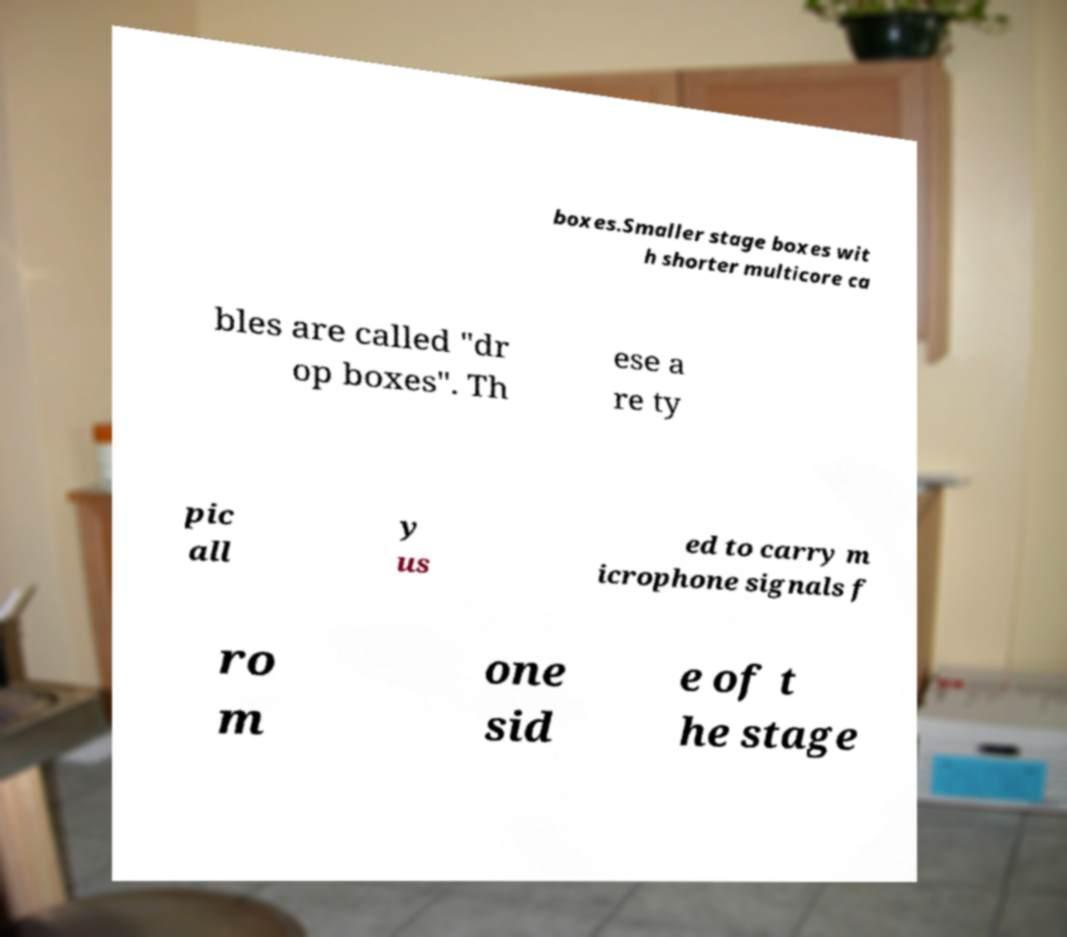Please read and relay the text visible in this image. What does it say? boxes.Smaller stage boxes wit h shorter multicore ca bles are called "dr op boxes". Th ese a re ty pic all y us ed to carry m icrophone signals f ro m one sid e of t he stage 